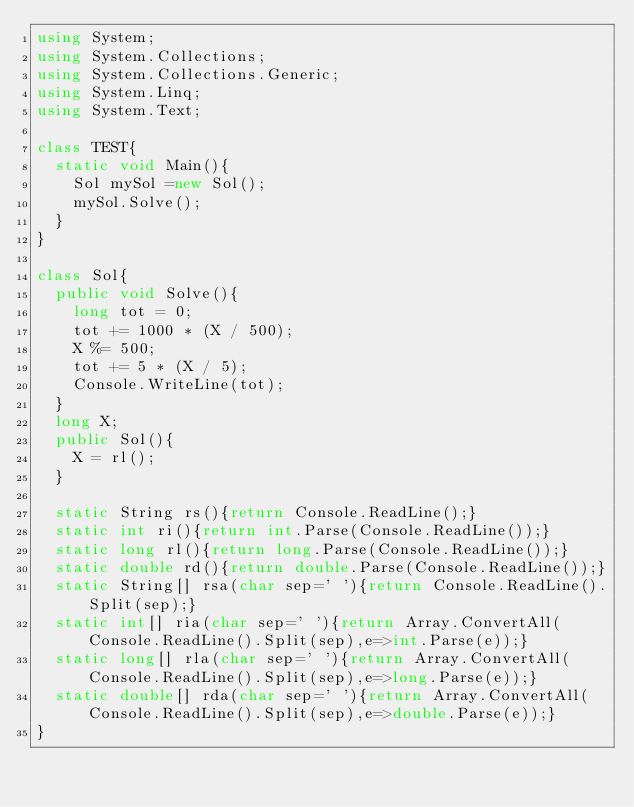Convert code to text. <code><loc_0><loc_0><loc_500><loc_500><_C#_>using System;
using System.Collections;
using System.Collections.Generic;
using System.Linq;
using System.Text;

class TEST{
	static void Main(){
		Sol mySol =new Sol();
		mySol.Solve();
	}
}

class Sol{
	public void Solve(){
		long tot = 0;
		tot += 1000 * (X / 500);
		X %= 500;
		tot += 5 * (X / 5);
		Console.WriteLine(tot);
	}
	long X;
	public Sol(){
		X = rl();
	}

	static String rs(){return Console.ReadLine();}
	static int ri(){return int.Parse(Console.ReadLine());}
	static long rl(){return long.Parse(Console.ReadLine());}
	static double rd(){return double.Parse(Console.ReadLine());}
	static String[] rsa(char sep=' '){return Console.ReadLine().Split(sep);}
	static int[] ria(char sep=' '){return Array.ConvertAll(Console.ReadLine().Split(sep),e=>int.Parse(e));}
	static long[] rla(char sep=' '){return Array.ConvertAll(Console.ReadLine().Split(sep),e=>long.Parse(e));}
	static double[] rda(char sep=' '){return Array.ConvertAll(Console.ReadLine().Split(sep),e=>double.Parse(e));}
}
</code> 